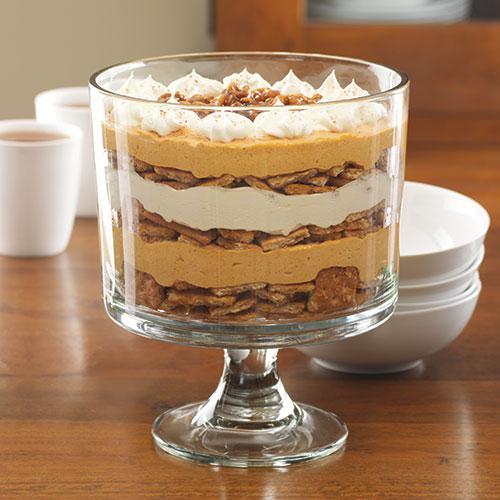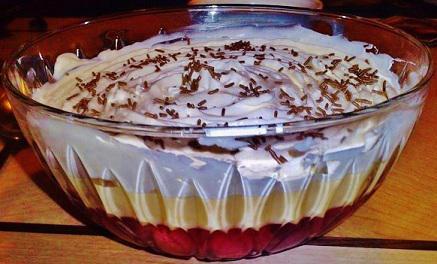The first image is the image on the left, the second image is the image on the right. Assess this claim about the two images: "in one of the images, there is a strawberry nestled on top of a pile of blueberries on a cake". Correct or not? Answer yes or no. No. The first image is the image on the left, the second image is the image on the right. Considering the images on both sides, is "In one image, a large dessert in a clear footed bowl is topped with a whole strawberry centered on a mound of blueberries, which are ringed by strawberry slices." valid? Answer yes or no. No. 